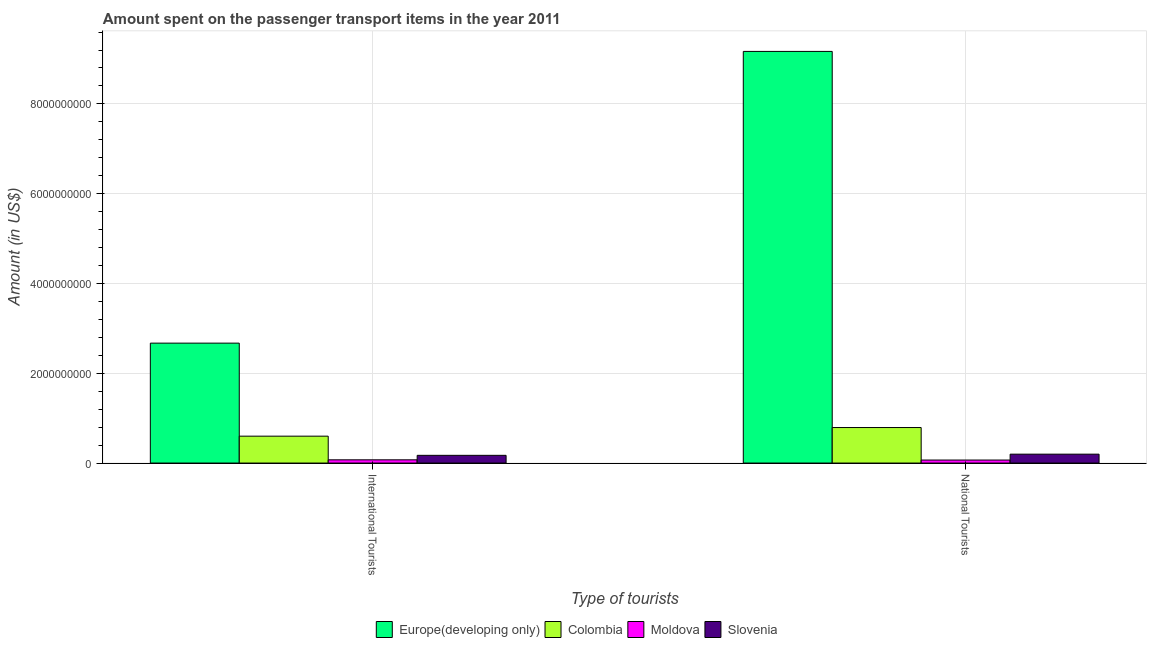How many groups of bars are there?
Make the answer very short. 2. How many bars are there on the 1st tick from the left?
Give a very brief answer. 4. What is the label of the 1st group of bars from the left?
Keep it short and to the point. International Tourists. What is the amount spent on transport items of international tourists in Colombia?
Provide a succinct answer. 5.99e+08. Across all countries, what is the maximum amount spent on transport items of national tourists?
Your response must be concise. 9.17e+09. Across all countries, what is the minimum amount spent on transport items of international tourists?
Offer a terse response. 7.20e+07. In which country was the amount spent on transport items of international tourists maximum?
Your response must be concise. Europe(developing only). In which country was the amount spent on transport items of national tourists minimum?
Ensure brevity in your answer.  Moldova. What is the total amount spent on transport items of national tourists in the graph?
Your answer should be compact. 1.02e+1. What is the difference between the amount spent on transport items of national tourists in Colombia and that in Moldova?
Make the answer very short. 7.24e+08. What is the difference between the amount spent on transport items of international tourists in Colombia and the amount spent on transport items of national tourists in Slovenia?
Your response must be concise. 4.01e+08. What is the average amount spent on transport items of national tourists per country?
Give a very brief answer. 2.56e+09. What is the difference between the amount spent on transport items of international tourists and amount spent on transport items of national tourists in Moldova?
Provide a succinct answer. 5.00e+06. What is the ratio of the amount spent on transport items of national tourists in Slovenia to that in Colombia?
Provide a short and direct response. 0.25. In how many countries, is the amount spent on transport items of national tourists greater than the average amount spent on transport items of national tourists taken over all countries?
Make the answer very short. 1. What does the 3rd bar from the left in National Tourists represents?
Keep it short and to the point. Moldova. What does the 2nd bar from the right in National Tourists represents?
Ensure brevity in your answer.  Moldova. How many bars are there?
Provide a short and direct response. 8. Are all the bars in the graph horizontal?
Your answer should be very brief. No. Does the graph contain any zero values?
Provide a succinct answer. No. Does the graph contain grids?
Make the answer very short. Yes. How many legend labels are there?
Offer a very short reply. 4. What is the title of the graph?
Give a very brief answer. Amount spent on the passenger transport items in the year 2011. Does "Korea (Democratic)" appear as one of the legend labels in the graph?
Provide a succinct answer. No. What is the label or title of the X-axis?
Keep it short and to the point. Type of tourists. What is the label or title of the Y-axis?
Provide a short and direct response. Amount (in US$). What is the Amount (in US$) of Europe(developing only) in International Tourists?
Provide a short and direct response. 2.67e+09. What is the Amount (in US$) in Colombia in International Tourists?
Your answer should be very brief. 5.99e+08. What is the Amount (in US$) in Moldova in International Tourists?
Provide a succinct answer. 7.20e+07. What is the Amount (in US$) of Slovenia in International Tourists?
Provide a succinct answer. 1.72e+08. What is the Amount (in US$) of Europe(developing only) in National Tourists?
Your answer should be very brief. 9.17e+09. What is the Amount (in US$) in Colombia in National Tourists?
Make the answer very short. 7.91e+08. What is the Amount (in US$) of Moldova in National Tourists?
Your response must be concise. 6.70e+07. What is the Amount (in US$) in Slovenia in National Tourists?
Offer a very short reply. 1.98e+08. Across all Type of tourists, what is the maximum Amount (in US$) in Europe(developing only)?
Provide a succinct answer. 9.17e+09. Across all Type of tourists, what is the maximum Amount (in US$) in Colombia?
Your answer should be compact. 7.91e+08. Across all Type of tourists, what is the maximum Amount (in US$) in Moldova?
Your answer should be very brief. 7.20e+07. Across all Type of tourists, what is the maximum Amount (in US$) of Slovenia?
Your answer should be compact. 1.98e+08. Across all Type of tourists, what is the minimum Amount (in US$) of Europe(developing only)?
Keep it short and to the point. 2.67e+09. Across all Type of tourists, what is the minimum Amount (in US$) of Colombia?
Your answer should be compact. 5.99e+08. Across all Type of tourists, what is the minimum Amount (in US$) in Moldova?
Provide a short and direct response. 6.70e+07. Across all Type of tourists, what is the minimum Amount (in US$) in Slovenia?
Offer a terse response. 1.72e+08. What is the total Amount (in US$) of Europe(developing only) in the graph?
Offer a terse response. 1.18e+1. What is the total Amount (in US$) of Colombia in the graph?
Keep it short and to the point. 1.39e+09. What is the total Amount (in US$) in Moldova in the graph?
Your response must be concise. 1.39e+08. What is the total Amount (in US$) in Slovenia in the graph?
Give a very brief answer. 3.70e+08. What is the difference between the Amount (in US$) of Europe(developing only) in International Tourists and that in National Tourists?
Your answer should be compact. -6.50e+09. What is the difference between the Amount (in US$) of Colombia in International Tourists and that in National Tourists?
Give a very brief answer. -1.92e+08. What is the difference between the Amount (in US$) of Slovenia in International Tourists and that in National Tourists?
Your answer should be compact. -2.60e+07. What is the difference between the Amount (in US$) in Europe(developing only) in International Tourists and the Amount (in US$) in Colombia in National Tourists?
Provide a succinct answer. 1.88e+09. What is the difference between the Amount (in US$) of Europe(developing only) in International Tourists and the Amount (in US$) of Moldova in National Tourists?
Provide a succinct answer. 2.60e+09. What is the difference between the Amount (in US$) in Europe(developing only) in International Tourists and the Amount (in US$) in Slovenia in National Tourists?
Your answer should be compact. 2.47e+09. What is the difference between the Amount (in US$) of Colombia in International Tourists and the Amount (in US$) of Moldova in National Tourists?
Your answer should be very brief. 5.32e+08. What is the difference between the Amount (in US$) in Colombia in International Tourists and the Amount (in US$) in Slovenia in National Tourists?
Offer a terse response. 4.01e+08. What is the difference between the Amount (in US$) in Moldova in International Tourists and the Amount (in US$) in Slovenia in National Tourists?
Make the answer very short. -1.26e+08. What is the average Amount (in US$) of Europe(developing only) per Type of tourists?
Make the answer very short. 5.92e+09. What is the average Amount (in US$) in Colombia per Type of tourists?
Your answer should be compact. 6.95e+08. What is the average Amount (in US$) in Moldova per Type of tourists?
Make the answer very short. 6.95e+07. What is the average Amount (in US$) of Slovenia per Type of tourists?
Offer a very short reply. 1.85e+08. What is the difference between the Amount (in US$) in Europe(developing only) and Amount (in US$) in Colombia in International Tourists?
Ensure brevity in your answer.  2.07e+09. What is the difference between the Amount (in US$) of Europe(developing only) and Amount (in US$) of Moldova in International Tourists?
Offer a terse response. 2.60e+09. What is the difference between the Amount (in US$) in Europe(developing only) and Amount (in US$) in Slovenia in International Tourists?
Keep it short and to the point. 2.50e+09. What is the difference between the Amount (in US$) in Colombia and Amount (in US$) in Moldova in International Tourists?
Make the answer very short. 5.27e+08. What is the difference between the Amount (in US$) in Colombia and Amount (in US$) in Slovenia in International Tourists?
Make the answer very short. 4.27e+08. What is the difference between the Amount (in US$) in Moldova and Amount (in US$) in Slovenia in International Tourists?
Keep it short and to the point. -1.00e+08. What is the difference between the Amount (in US$) of Europe(developing only) and Amount (in US$) of Colombia in National Tourists?
Provide a short and direct response. 8.38e+09. What is the difference between the Amount (in US$) in Europe(developing only) and Amount (in US$) in Moldova in National Tourists?
Offer a terse response. 9.10e+09. What is the difference between the Amount (in US$) of Europe(developing only) and Amount (in US$) of Slovenia in National Tourists?
Keep it short and to the point. 8.97e+09. What is the difference between the Amount (in US$) of Colombia and Amount (in US$) of Moldova in National Tourists?
Offer a very short reply. 7.24e+08. What is the difference between the Amount (in US$) of Colombia and Amount (in US$) of Slovenia in National Tourists?
Your response must be concise. 5.93e+08. What is the difference between the Amount (in US$) in Moldova and Amount (in US$) in Slovenia in National Tourists?
Provide a short and direct response. -1.31e+08. What is the ratio of the Amount (in US$) in Europe(developing only) in International Tourists to that in National Tourists?
Make the answer very short. 0.29. What is the ratio of the Amount (in US$) of Colombia in International Tourists to that in National Tourists?
Ensure brevity in your answer.  0.76. What is the ratio of the Amount (in US$) of Moldova in International Tourists to that in National Tourists?
Your answer should be very brief. 1.07. What is the ratio of the Amount (in US$) in Slovenia in International Tourists to that in National Tourists?
Keep it short and to the point. 0.87. What is the difference between the highest and the second highest Amount (in US$) in Europe(developing only)?
Provide a short and direct response. 6.50e+09. What is the difference between the highest and the second highest Amount (in US$) of Colombia?
Your answer should be very brief. 1.92e+08. What is the difference between the highest and the second highest Amount (in US$) in Slovenia?
Your response must be concise. 2.60e+07. What is the difference between the highest and the lowest Amount (in US$) of Europe(developing only)?
Offer a very short reply. 6.50e+09. What is the difference between the highest and the lowest Amount (in US$) in Colombia?
Provide a succinct answer. 1.92e+08. What is the difference between the highest and the lowest Amount (in US$) in Slovenia?
Your answer should be very brief. 2.60e+07. 